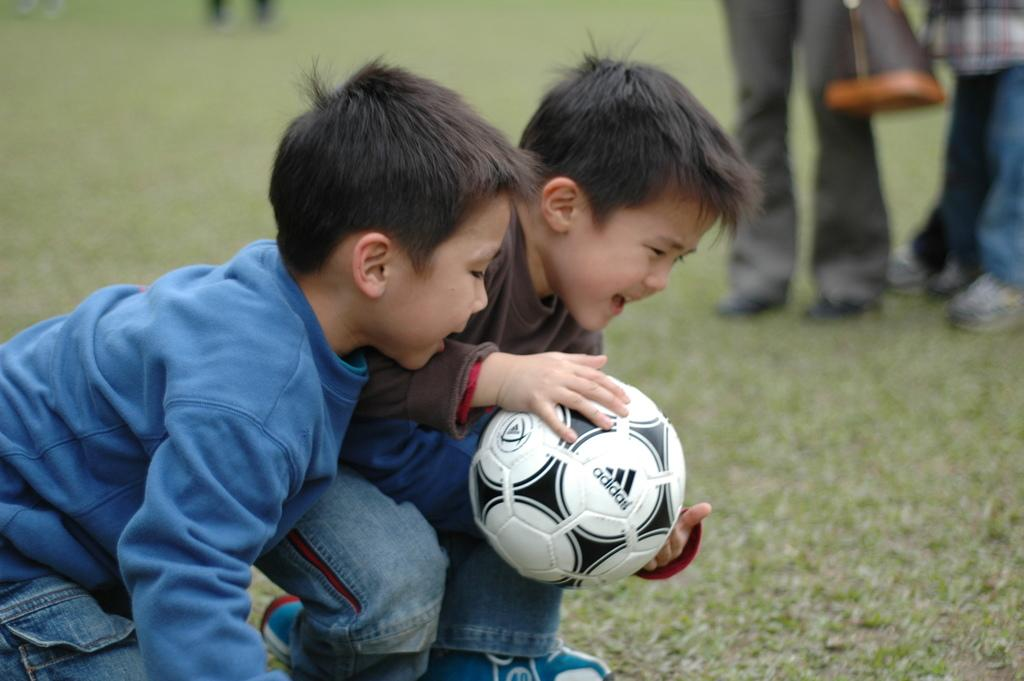How many kids are in the image? There are two kids in the image. What are the kids doing in the image? The kids are fighting for a football. How can you describe the appearance of the kids? The kids are cute. What is the kid wearing a blue t-shirt and jeans wearing? The kid wearing a blue t-shirt and jeans is wearing a blue t-shirt and jeans. What is the other kid wearing? The other kid is wearing a brown t-shirt and jeans. What type of horn can be seen on the football in the image? There is no horn present on the football in the image. How many slaves are visible in the image? There are no slaves present in the image; it features two kids fighting for a football. 